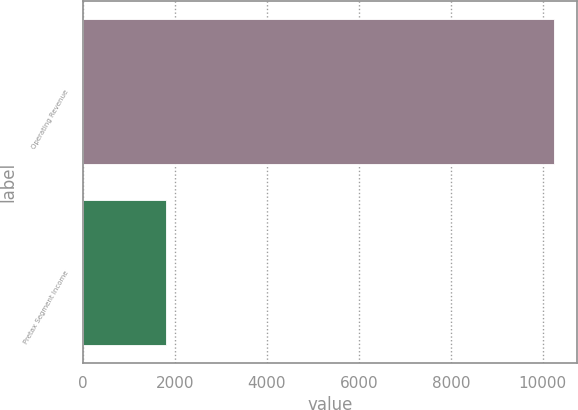<chart> <loc_0><loc_0><loc_500><loc_500><bar_chart><fcel>Operating Revenue<fcel>Pretax Segment Income<nl><fcel>10239<fcel>1801<nl></chart> 